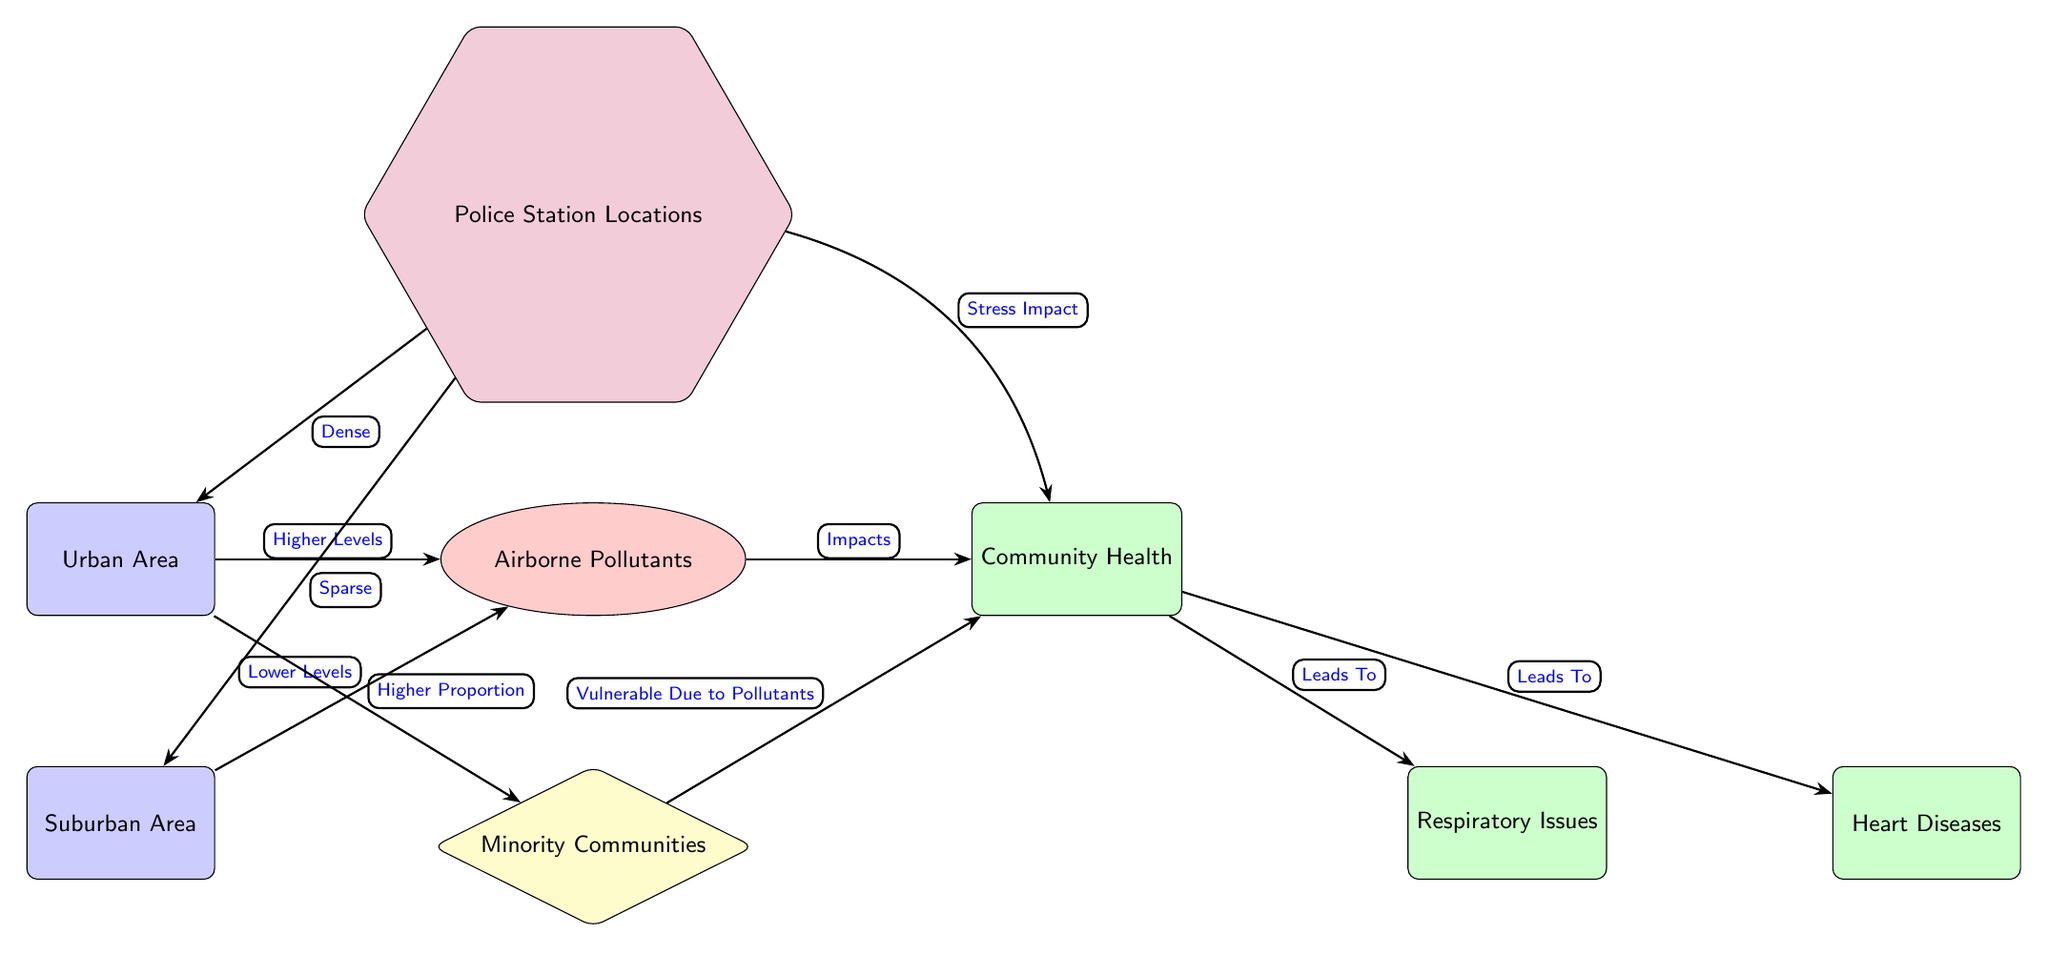What type of area shows higher levels of airborne pollutants? The diagram indicates that urban areas have "Higher Levels" of airborne pollutants compared to suburban areas, as indicated by the connecting edge between the urban node and the pollutants node.
Answer: Urban Area What health issue is connected to community health in the diagram? The arrow leading from the health node to the respiratory issues node illustrates that community health impacts respiratory issues, as marked by the label "Leads To".
Answer: Respiratory Issues How many police station locations are indicated in the urban area? The diagram signifies that police station locations are labeled as "Dense" in urban areas, which indicates a higher concentration compared to suburban regions without stating a specific number.
Answer: Dense What relationship exists between minority communities and health? The diagram connects minority communities to health by showing that they are "Vulnerable Due to Pollutants," leading to negative impacts on health. This relationship is termed through an edge connecting the minority node to the health node.
Answer: Vulnerable Due to Pollutants What impact do airborne pollutants have on community health? The diagram explicitly states that airborne pollutants "Impacts" community health, as shown by the arrow connecting the pollution node to the health node.
Answer: Impacts What qualitative difference in police presence is noted between urban and suburban areas? The diagram shows that police stations in urban areas are described as "Dense," while those in suburban areas are noted as "Sparse," indicating a significant qualitative difference in police presence.
Answer: Sparse Which health issue is directly linked to community health aside from respiratory issues? The diagram indicates that aside from respiratory issues, "Heart Diseases" is another health concern linked to community health, as shown by its direct connection to the health node.
Answer: Heart Diseases What community type is represented as having a higher proportion in urban areas? The diagram indicates that urban areas have a "Higher Proportion" of minority communities, showcasing a specific demographic aspect of these areas.
Answer: Minority Communities 